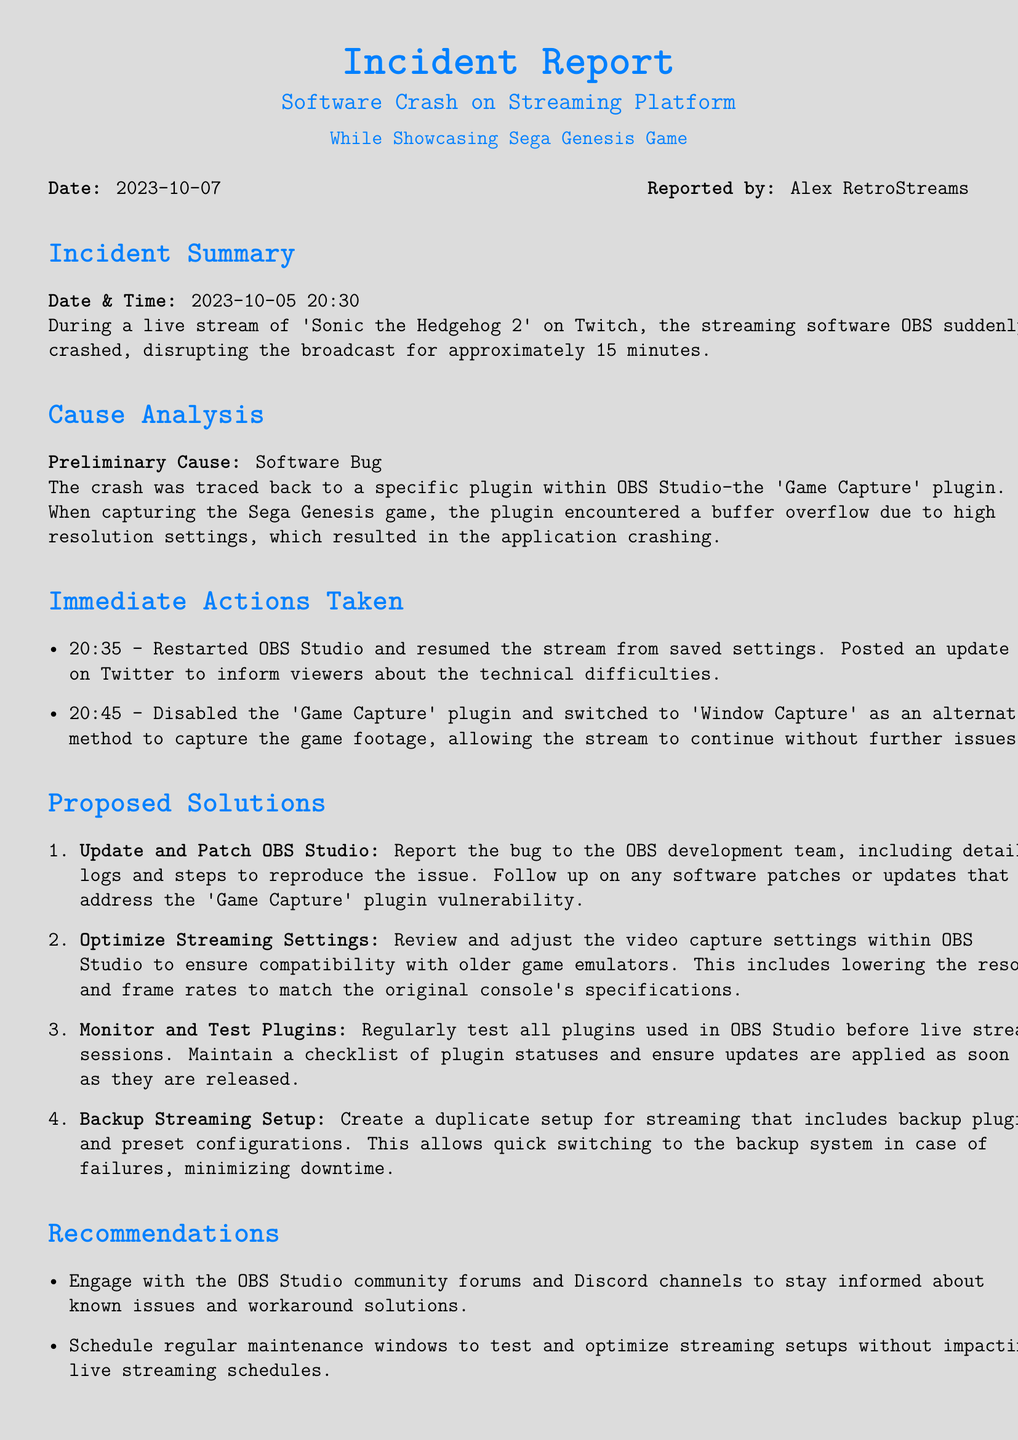what was the date of the incident? The incident occurred on October 5, 2023, at 20:30.
Answer: 2023-10-05 who reported the incident? The incident was reported by Alex RetroStreams.
Answer: Alex RetroStreams what caused the software crash? The crash was caused by a buffer overflow in the 'Game Capture' plugin.
Answer: Software Bug how long did the broadcast disruption last? The broadcast was disrupted for approximately 15 minutes.
Answer: 15 minutes what alternative method was used to capture the game footage? 'Window Capture' was used as an alternative method.
Answer: Window Capture how many proposed solutions are listed in the report? There are four proposed solutions mentioned in the report.
Answer: 4 when did the immediate action of restarting OBS occur? The software was restarted at 20:35.
Answer: 20:35 what was the main recommendation for engaging with the community? To engage with the OBS Studio community forums and Discord channels.
Answer: Community forums and Discord channels what type of bug was reported in the incident? A vulnerability in the 'Game Capture' plugin.
Answer: Plugin vulnerability 